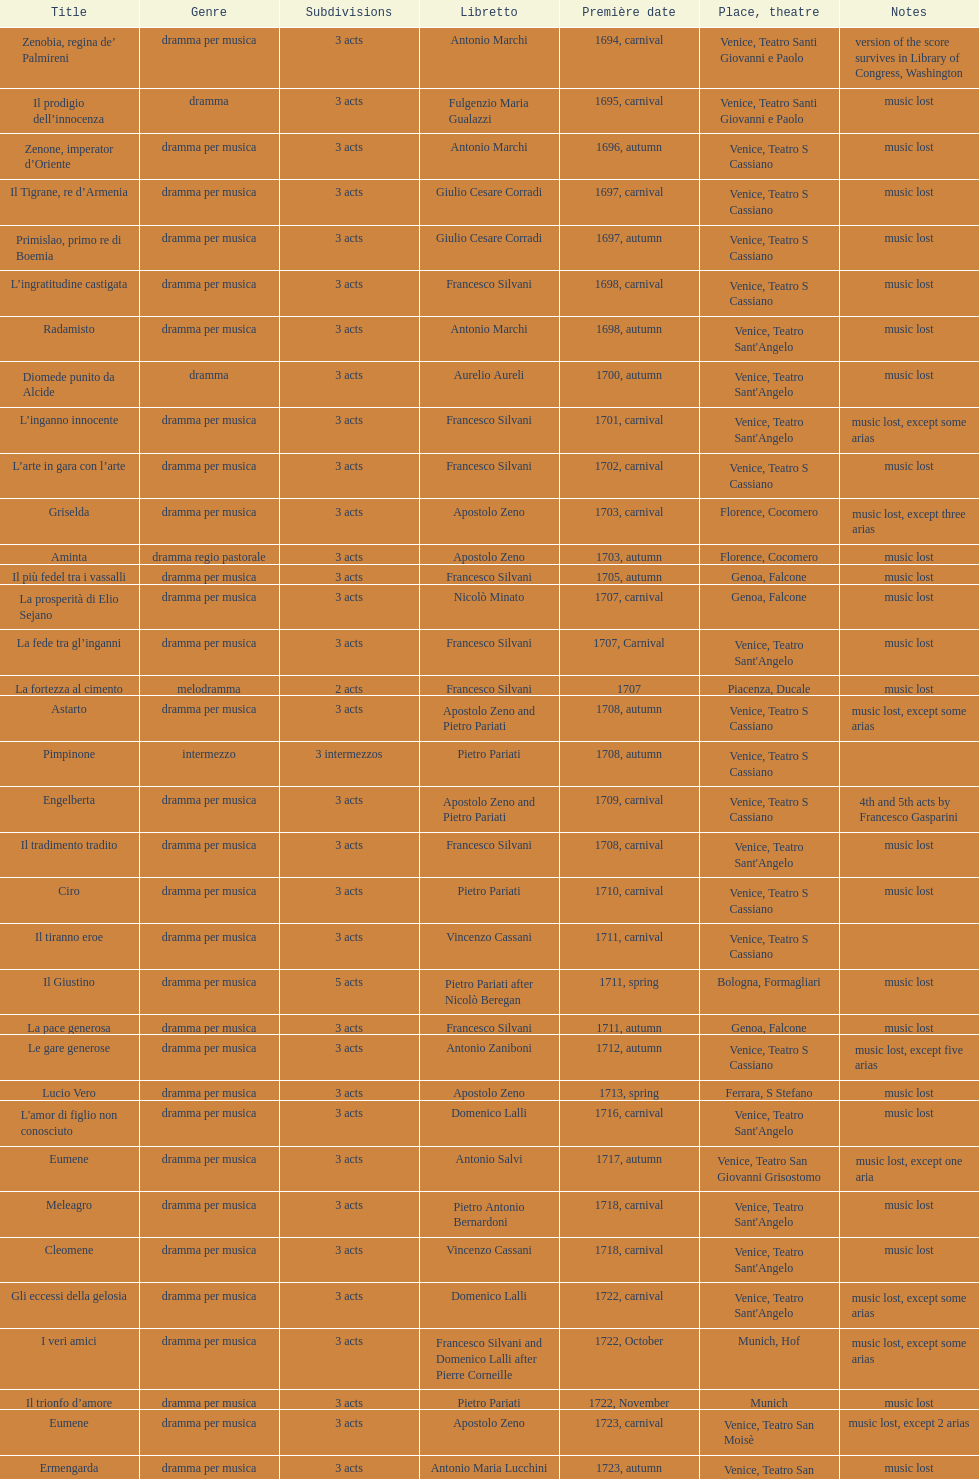Can you give me this table as a dict? {'header': ['Title', 'Genre', 'Sub\xaddivisions', 'Libretto', 'Première date', 'Place, theatre', 'Notes'], 'rows': [['Zenobia, regina de’ Palmireni', 'dramma per musica', '3 acts', 'Antonio Marchi', '1694, carnival', 'Venice, Teatro Santi Giovanni e Paolo', 'version of the score survives in Library of Congress, Washington'], ['Il prodigio dell’innocenza', 'dramma', '3 acts', 'Fulgenzio Maria Gualazzi', '1695, carnival', 'Venice, Teatro Santi Giovanni e Paolo', 'music lost'], ['Zenone, imperator d’Oriente', 'dramma per musica', '3 acts', 'Antonio Marchi', '1696, autumn', 'Venice, Teatro S Cassiano', 'music lost'], ['Il Tigrane, re d’Armenia', 'dramma per musica', '3 acts', 'Giulio Cesare Corradi', '1697, carnival', 'Venice, Teatro S Cassiano', 'music lost'], ['Primislao, primo re di Boemia', 'dramma per musica', '3 acts', 'Giulio Cesare Corradi', '1697, autumn', 'Venice, Teatro S Cassiano', 'music lost'], ['L’ingratitudine castigata', 'dramma per musica', '3 acts', 'Francesco Silvani', '1698, carnival', 'Venice, Teatro S Cassiano', 'music lost'], ['Radamisto', 'dramma per musica', '3 acts', 'Antonio Marchi', '1698, autumn', "Venice, Teatro Sant'Angelo", 'music lost'], ['Diomede punito da Alcide', 'dramma', '3 acts', 'Aurelio Aureli', '1700, autumn', "Venice, Teatro Sant'Angelo", 'music lost'], ['L’inganno innocente', 'dramma per musica', '3 acts', 'Francesco Silvani', '1701, carnival', "Venice, Teatro Sant'Angelo", 'music lost, except some arias'], ['L’arte in gara con l’arte', 'dramma per musica', '3 acts', 'Francesco Silvani', '1702, carnival', 'Venice, Teatro S Cassiano', 'music lost'], ['Griselda', 'dramma per musica', '3 acts', 'Apostolo Zeno', '1703, carnival', 'Florence, Cocomero', 'music lost, except three arias'], ['Aminta', 'dramma regio pastorale', '3 acts', 'Apostolo Zeno', '1703, autumn', 'Florence, Cocomero', 'music lost'], ['Il più fedel tra i vassalli', 'dramma per musica', '3 acts', 'Francesco Silvani', '1705, autumn', 'Genoa, Falcone', 'music lost'], ['La prosperità di Elio Sejano', 'dramma per musica', '3 acts', 'Nicolò Minato', '1707, carnival', 'Genoa, Falcone', 'music lost'], ['La fede tra gl’inganni', 'dramma per musica', '3 acts', 'Francesco Silvani', '1707, Carnival', "Venice, Teatro Sant'Angelo", 'music lost'], ['La fortezza al cimento', 'melodramma', '2 acts', 'Francesco Silvani', '1707', 'Piacenza, Ducale', 'music lost'], ['Astarto', 'dramma per musica', '3 acts', 'Apostolo Zeno and Pietro Pariati', '1708, autumn', 'Venice, Teatro S Cassiano', 'music lost, except some arias'], ['Pimpinone', 'intermezzo', '3 intermezzos', 'Pietro Pariati', '1708, autumn', 'Venice, Teatro S Cassiano', ''], ['Engelberta', 'dramma per musica', '3 acts', 'Apostolo Zeno and Pietro Pariati', '1709, carnival', 'Venice, Teatro S Cassiano', '4th and 5th acts by Francesco Gasparini'], ['Il tradimento tradito', 'dramma per musica', '3 acts', 'Francesco Silvani', '1708, carnival', "Venice, Teatro Sant'Angelo", 'music lost'], ['Ciro', 'dramma per musica', '3 acts', 'Pietro Pariati', '1710, carnival', 'Venice, Teatro S Cassiano', 'music lost'], ['Il tiranno eroe', 'dramma per musica', '3 acts', 'Vincenzo Cassani', '1711, carnival', 'Venice, Teatro S Cassiano', ''], ['Il Giustino', 'dramma per musica', '5 acts', 'Pietro Pariati after Nicolò Beregan', '1711, spring', 'Bologna, Formagliari', 'music lost'], ['La pace generosa', 'dramma per musica', '3 acts', 'Francesco Silvani', '1711, autumn', 'Genoa, Falcone', 'music lost'], ['Le gare generose', 'dramma per musica', '3 acts', 'Antonio Zaniboni', '1712, autumn', 'Venice, Teatro S Cassiano', 'music lost, except five arias'], ['Lucio Vero', 'dramma per musica', '3 acts', 'Apostolo Zeno', '1713, spring', 'Ferrara, S Stefano', 'music lost'], ["L'amor di figlio non conosciuto", 'dramma per musica', '3 acts', 'Domenico Lalli', '1716, carnival', "Venice, Teatro Sant'Angelo", 'music lost'], ['Eumene', 'dramma per musica', '3 acts', 'Antonio Salvi', '1717, autumn', 'Venice, Teatro San Giovanni Grisostomo', 'music lost, except one aria'], ['Meleagro', 'dramma per musica', '3 acts', 'Pietro Antonio Bernardoni', '1718, carnival', "Venice, Teatro Sant'Angelo", 'music lost'], ['Cleomene', 'dramma per musica', '3 acts', 'Vincenzo Cassani', '1718, carnival', "Venice, Teatro Sant'Angelo", 'music lost'], ['Gli eccessi della gelosia', 'dramma per musica', '3 acts', 'Domenico Lalli', '1722, carnival', "Venice, Teatro Sant'Angelo", 'music lost, except some arias'], ['I veri amici', 'dramma per musica', '3 acts', 'Francesco Silvani and Domenico Lalli after Pierre Corneille', '1722, October', 'Munich, Hof', 'music lost, except some arias'], ['Il trionfo d’amore', 'dramma per musica', '3 acts', 'Pietro Pariati', '1722, November', 'Munich', 'music lost'], ['Eumene', 'dramma per musica', '3 acts', 'Apostolo Zeno', '1723, carnival', 'Venice, Teatro San Moisè', 'music lost, except 2 arias'], ['Ermengarda', 'dramma per musica', '3 acts', 'Antonio Maria Lucchini', '1723, autumn', 'Venice, Teatro San Moisè', 'music lost'], ['Antigono, tutore di Filippo, re di Macedonia', 'tragedia', '5 acts', 'Giovanni Piazzon', '1724, carnival', 'Venice, Teatro San Moisè', '5th act by Giovanni Porta, music lost'], ['Scipione nelle Spagne', 'dramma per musica', '3 acts', 'Apostolo Zeno', '1724, Ascension', 'Venice, Teatro San Samuele', 'music lost'], ['Laodice', 'dramma per musica', '3 acts', 'Angelo Schietti', '1724, autumn', 'Venice, Teatro San Moisè', 'music lost, except 2 arias'], ['Didone abbandonata', 'tragedia', '3 acts', 'Metastasio', '1725, carnival', 'Venice, Teatro S Cassiano', 'music lost'], ["L'impresario delle Isole Canarie", 'intermezzo', '2 acts', 'Metastasio', '1725, carnival', 'Venice, Teatro S Cassiano', 'music lost'], ['Alcina delusa da Ruggero', 'dramma per musica', '3 acts', 'Antonio Marchi', '1725, autumn', 'Venice, Teatro S Cassiano', 'music lost'], ['I rivali generosi', 'dramma per musica', '3 acts', 'Apostolo Zeno', '1725', 'Brescia, Nuovo', ''], ['La Statira', 'dramma per musica', '3 acts', 'Apostolo Zeno and Pietro Pariati', '1726, Carnival', 'Rome, Teatro Capranica', ''], ['Malsazio e Fiammetta', 'intermezzo', '', '', '1726, Carnival', 'Rome, Teatro Capranica', ''], ['Il trionfo di Armida', 'dramma per musica', '3 acts', 'Girolamo Colatelli after Torquato Tasso', '1726, autumn', 'Venice, Teatro San Moisè', 'music lost'], ['L’incostanza schernita', 'dramma comico-pastorale', '3 acts', 'Vincenzo Cassani', '1727, Ascension', 'Venice, Teatro San Samuele', 'music lost, except some arias'], ['Le due rivali in amore', 'dramma per musica', '3 acts', 'Aurelio Aureli', '1728, autumn', 'Venice, Teatro San Moisè', 'music lost'], ['Il Satrapone', 'intermezzo', '', 'Salvi', '1729', 'Parma, Omodeo', ''], ['Li stratagemmi amorosi', 'dramma per musica', '3 acts', 'F Passerini', '1730, carnival', 'Venice, Teatro San Moisè', 'music lost'], ['Elenia', 'dramma per musica', '3 acts', 'Luisa Bergalli', '1730, carnival', "Venice, Teatro Sant'Angelo", 'music lost'], ['Merope', 'dramma', '3 acts', 'Apostolo Zeno', '1731, autumn', 'Prague, Sporck Theater', 'mostly by Albinoni, music lost'], ['Il più infedel tra gli amanti', 'dramma per musica', '3 acts', 'Angelo Schietti', '1731, autumn', 'Treviso, Dolphin', 'music lost'], ['Ardelinda', 'dramma', '3 acts', 'Bartolomeo Vitturi', '1732, autumn', "Venice, Teatro Sant'Angelo", 'music lost, except five arias'], ['Candalide', 'dramma per musica', '3 acts', 'Bartolomeo Vitturi', '1734, carnival', "Venice, Teatro Sant'Angelo", 'music lost'], ['Artamene', 'dramma per musica', '3 acts', 'Bartolomeo Vitturi', '1741, carnival', "Venice, Teatro Sant'Angelo", 'music lost']]} How many were unleashed after zenone, imperator d'oriente? 52. 